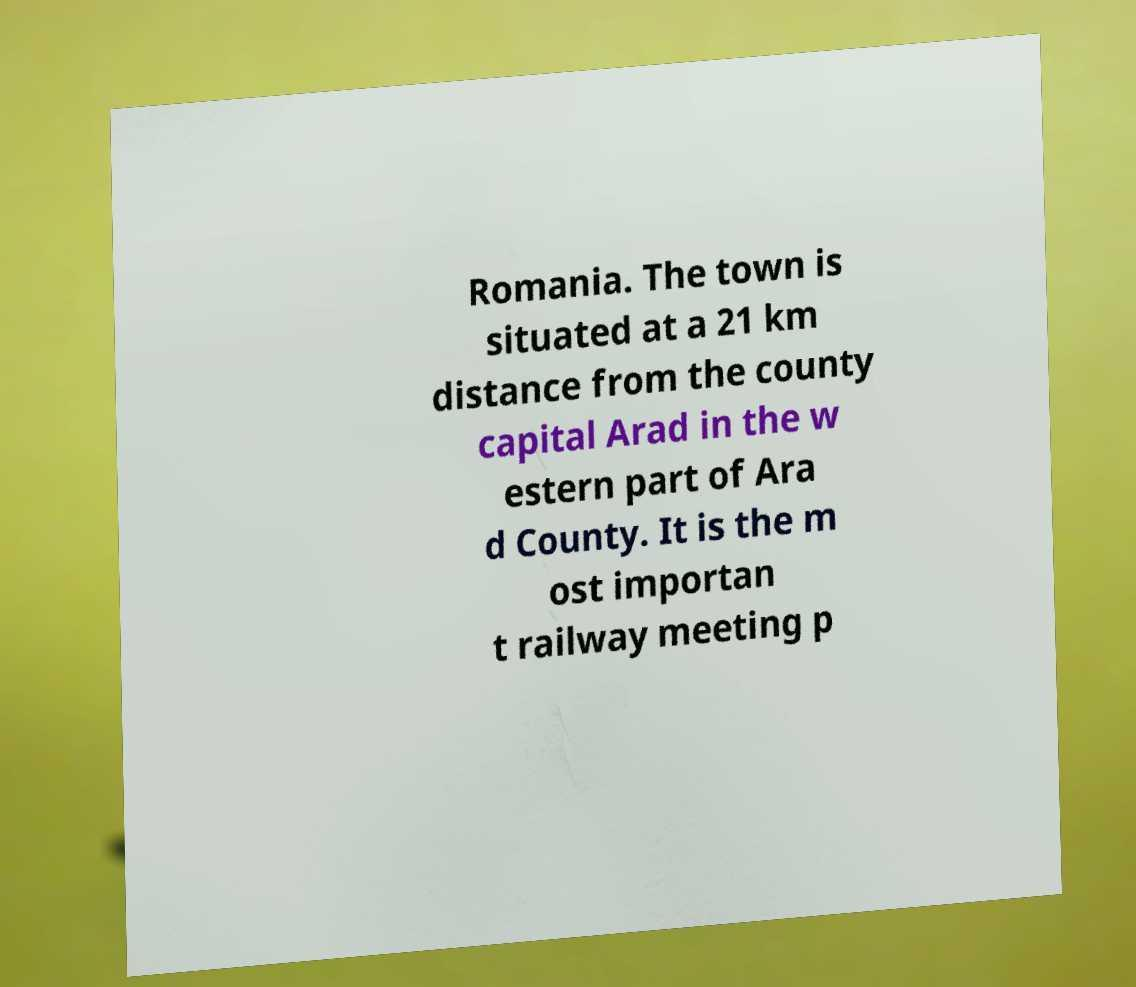What messages or text are displayed in this image? I need them in a readable, typed format. Romania. The town is situated at a 21 km distance from the county capital Arad in the w estern part of Ara d County. It is the m ost importan t railway meeting p 